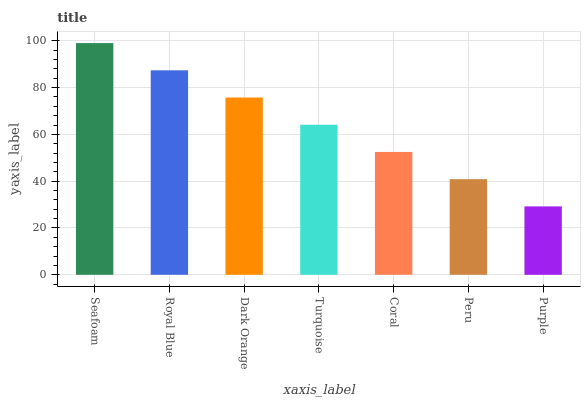Is Purple the minimum?
Answer yes or no. Yes. Is Seafoam the maximum?
Answer yes or no. Yes. Is Royal Blue the minimum?
Answer yes or no. No. Is Royal Blue the maximum?
Answer yes or no. No. Is Seafoam greater than Royal Blue?
Answer yes or no. Yes. Is Royal Blue less than Seafoam?
Answer yes or no. Yes. Is Royal Blue greater than Seafoam?
Answer yes or no. No. Is Seafoam less than Royal Blue?
Answer yes or no. No. Is Turquoise the high median?
Answer yes or no. Yes. Is Turquoise the low median?
Answer yes or no. Yes. Is Seafoam the high median?
Answer yes or no. No. Is Peru the low median?
Answer yes or no. No. 